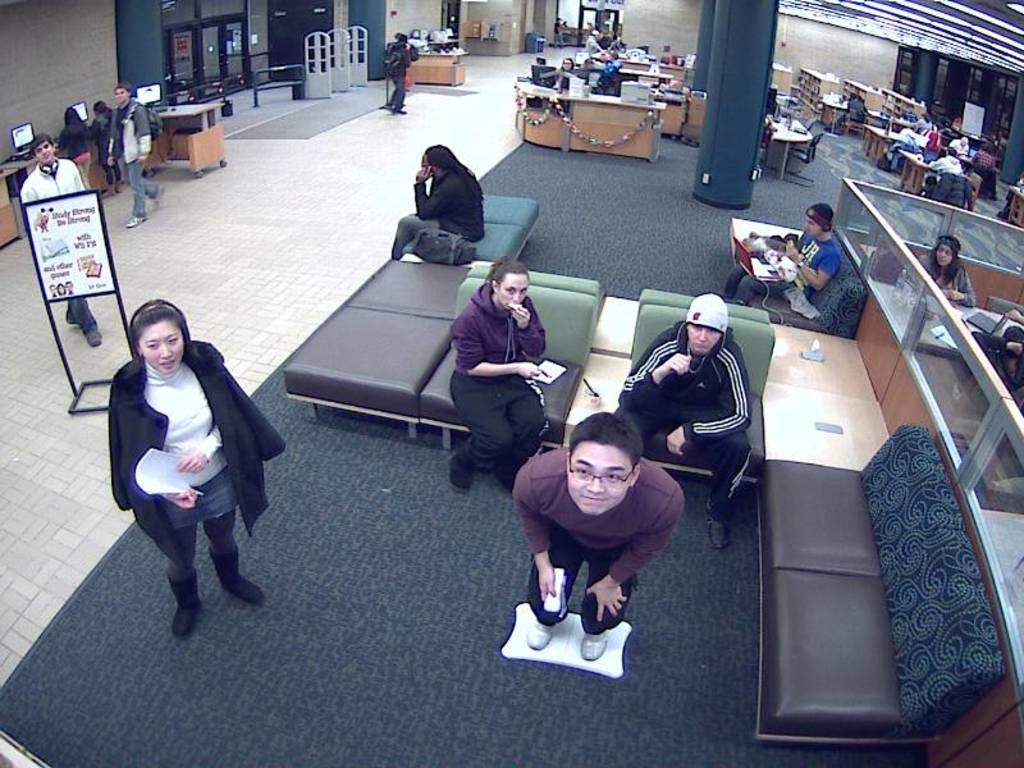How would you summarize this image in a sentence or two? There are people sitting on sofa and standing. In the back there are pillars, cabins, doors and walls. On the left side there is a board. 